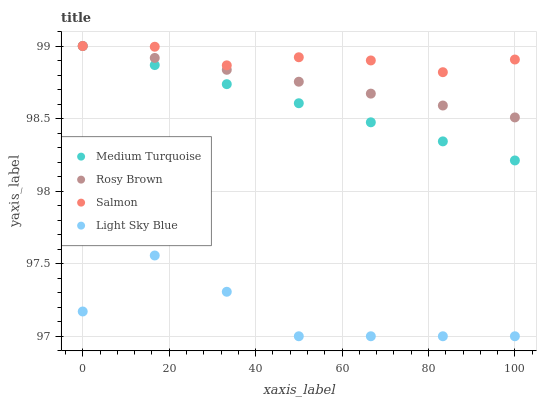Does Light Sky Blue have the minimum area under the curve?
Answer yes or no. Yes. Does Salmon have the maximum area under the curve?
Answer yes or no. Yes. Does Medium Turquoise have the minimum area under the curve?
Answer yes or no. No. Does Medium Turquoise have the maximum area under the curve?
Answer yes or no. No. Is Medium Turquoise the smoothest?
Answer yes or no. Yes. Is Light Sky Blue the roughest?
Answer yes or no. Yes. Is Salmon the smoothest?
Answer yes or no. No. Is Salmon the roughest?
Answer yes or no. No. Does Light Sky Blue have the lowest value?
Answer yes or no. Yes. Does Medium Turquoise have the lowest value?
Answer yes or no. No. Does Medium Turquoise have the highest value?
Answer yes or no. Yes. Does Light Sky Blue have the highest value?
Answer yes or no. No. Is Light Sky Blue less than Medium Turquoise?
Answer yes or no. Yes. Is Rosy Brown greater than Light Sky Blue?
Answer yes or no. Yes. Does Salmon intersect Medium Turquoise?
Answer yes or no. Yes. Is Salmon less than Medium Turquoise?
Answer yes or no. No. Is Salmon greater than Medium Turquoise?
Answer yes or no. No. Does Light Sky Blue intersect Medium Turquoise?
Answer yes or no. No. 